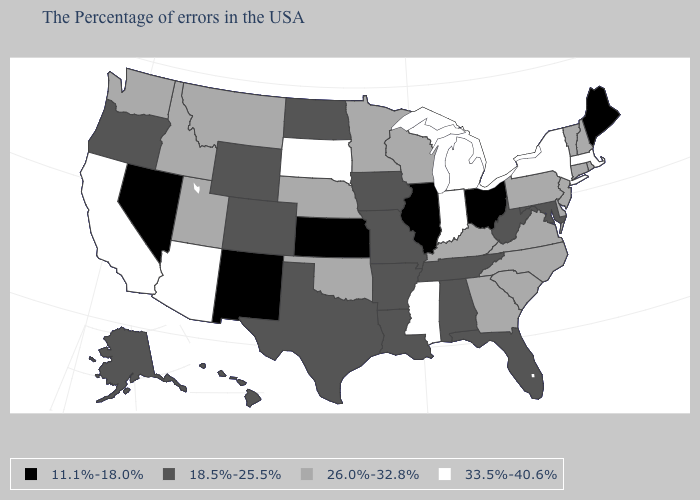What is the value of New Jersey?
Write a very short answer. 26.0%-32.8%. Name the states that have a value in the range 18.5%-25.5%?
Write a very short answer. Maryland, West Virginia, Florida, Alabama, Tennessee, Louisiana, Missouri, Arkansas, Iowa, Texas, North Dakota, Wyoming, Colorado, Oregon, Alaska, Hawaii. Which states have the highest value in the USA?
Be succinct. Massachusetts, New York, Michigan, Indiana, Mississippi, South Dakota, Arizona, California. Which states hav the highest value in the MidWest?
Keep it brief. Michigan, Indiana, South Dakota. Among the states that border Illinois , which have the lowest value?
Short answer required. Missouri, Iowa. Name the states that have a value in the range 18.5%-25.5%?
Short answer required. Maryland, West Virginia, Florida, Alabama, Tennessee, Louisiana, Missouri, Arkansas, Iowa, Texas, North Dakota, Wyoming, Colorado, Oregon, Alaska, Hawaii. Does the map have missing data?
Answer briefly. No. What is the highest value in states that border Montana?
Keep it brief. 33.5%-40.6%. What is the value of Michigan?
Short answer required. 33.5%-40.6%. What is the value of Wyoming?
Answer briefly. 18.5%-25.5%. Is the legend a continuous bar?
Keep it brief. No. Name the states that have a value in the range 26.0%-32.8%?
Answer briefly. Rhode Island, New Hampshire, Vermont, Connecticut, New Jersey, Delaware, Pennsylvania, Virginia, North Carolina, South Carolina, Georgia, Kentucky, Wisconsin, Minnesota, Nebraska, Oklahoma, Utah, Montana, Idaho, Washington. What is the lowest value in the MidWest?
Answer briefly. 11.1%-18.0%. Among the states that border South Dakota , which have the highest value?
Be succinct. Minnesota, Nebraska, Montana. What is the highest value in the USA?
Quick response, please. 33.5%-40.6%. 